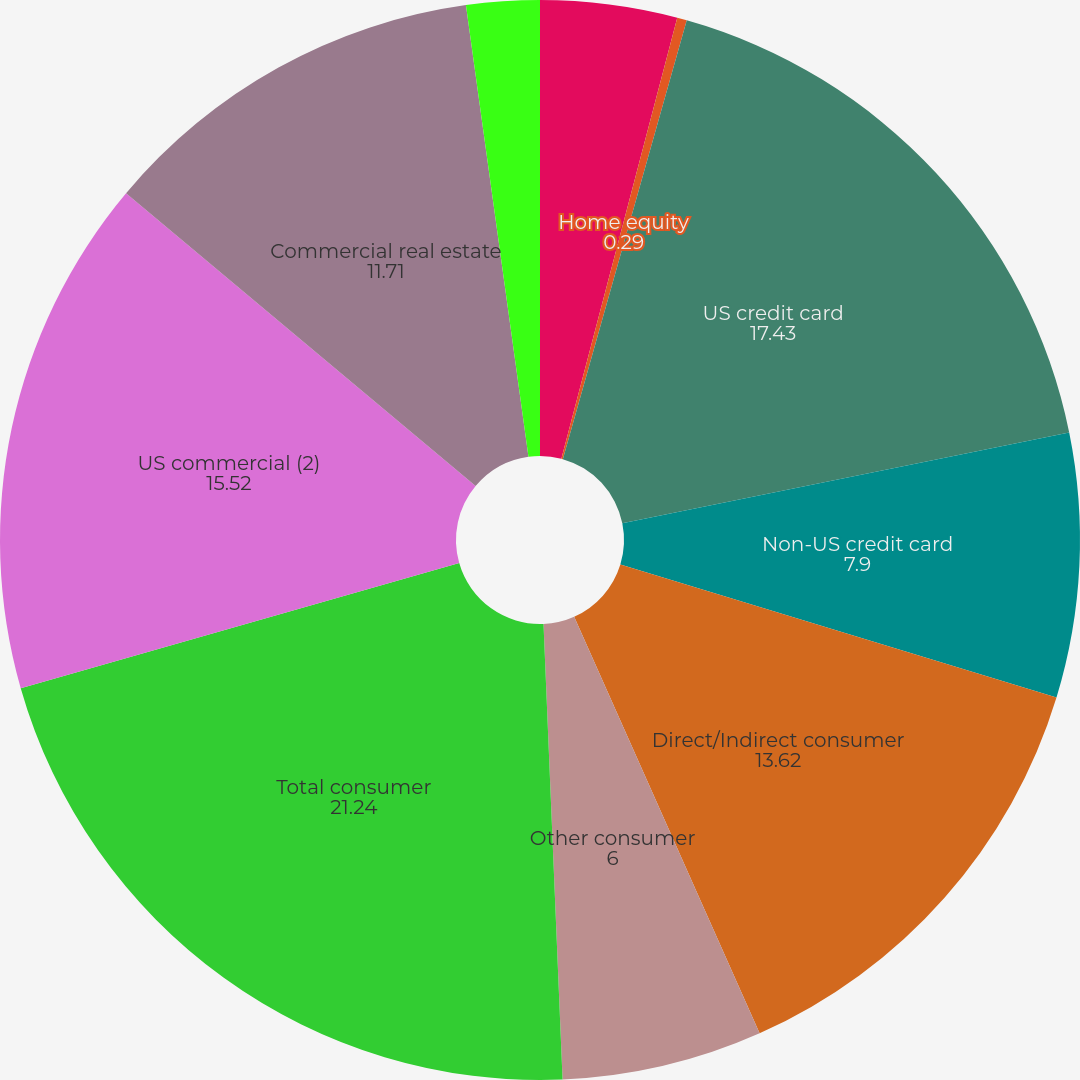Convert chart to OTSL. <chart><loc_0><loc_0><loc_500><loc_500><pie_chart><fcel>Residential mortgage<fcel>Home equity<fcel>US credit card<fcel>Non-US credit card<fcel>Direct/Indirect consumer<fcel>Other consumer<fcel>Total consumer<fcel>US commercial (2)<fcel>Commercial real estate<fcel>Commercial lease financing<nl><fcel>4.09%<fcel>0.29%<fcel>17.43%<fcel>7.9%<fcel>13.62%<fcel>6.0%<fcel>21.24%<fcel>15.52%<fcel>11.71%<fcel>2.19%<nl></chart> 